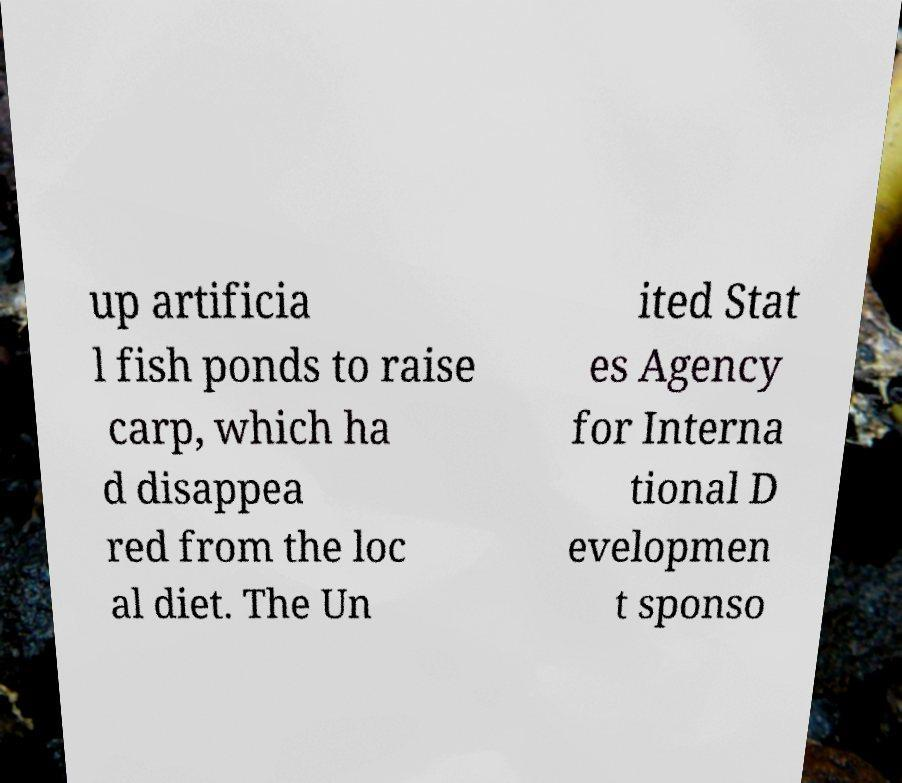There's text embedded in this image that I need extracted. Can you transcribe it verbatim? up artificia l fish ponds to raise carp, which ha d disappea red from the loc al diet. The Un ited Stat es Agency for Interna tional D evelopmen t sponso 